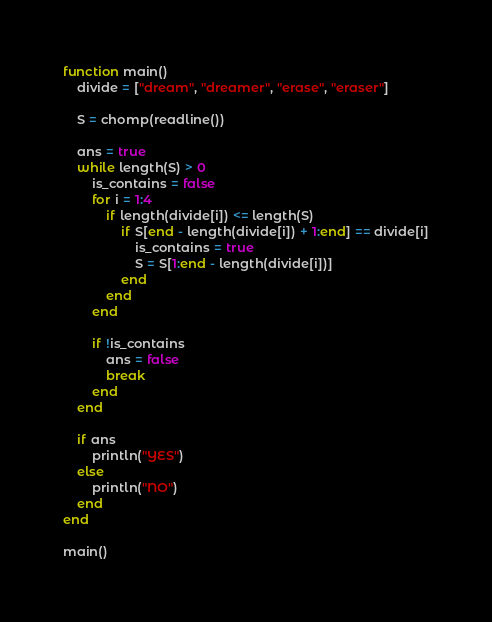Convert code to text. <code><loc_0><loc_0><loc_500><loc_500><_Julia_>function main()
    divide = ["dream", "dreamer", "erase", "eraser"]

    S = chomp(readline())

    ans = true
    while length(S) > 0
        is_contains = false
        for i = 1:4
            if length(divide[i]) <= length(S)
                if S[end - length(divide[i]) + 1:end] == divide[i]
                    is_contains = true
                    S = S[1:end - length(divide[i])]
                end
            end
        end

        if !is_contains
            ans = false
            break
        end
    end

    if ans
        println("YES")
    else
        println("NO")
    end
end

main()
</code> 